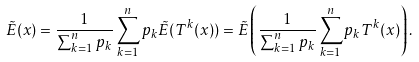Convert formula to latex. <formula><loc_0><loc_0><loc_500><loc_500>\tilde { E } ( x ) = \frac { 1 } { \sum _ { k = 1 } ^ { n } p _ { k } } \sum _ { k = 1 } ^ { n } p _ { k } \tilde { E } ( T ^ { k } ( x ) ) = \tilde { E } \left ( \frac { 1 } { \sum _ { k = 1 } ^ { n } p _ { k } } \sum _ { k = 1 } ^ { n } p _ { k } T ^ { k } ( x ) \right ) .</formula> 